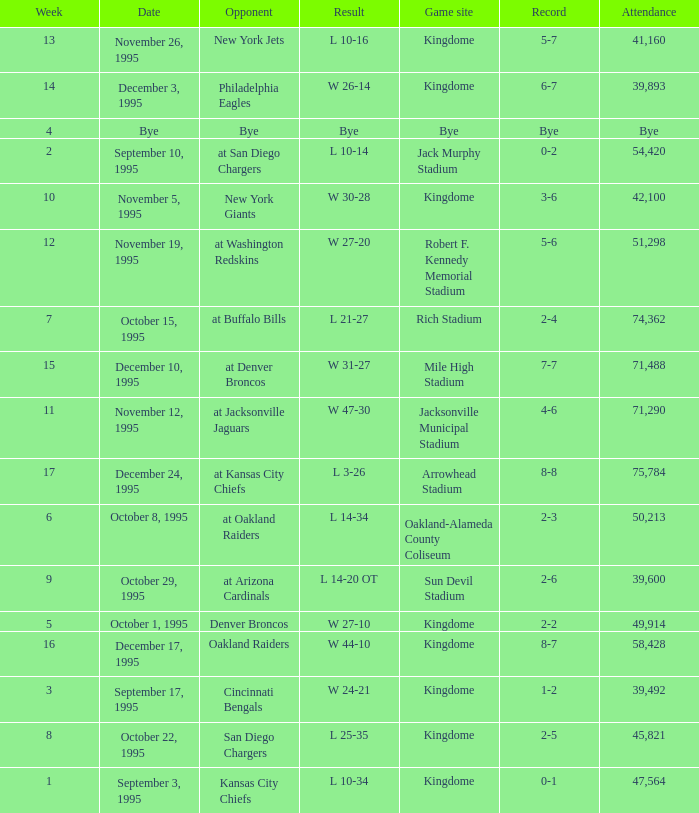Who was the opponent when the Seattle Seahawks had a record of 0-1? Kansas City Chiefs. 